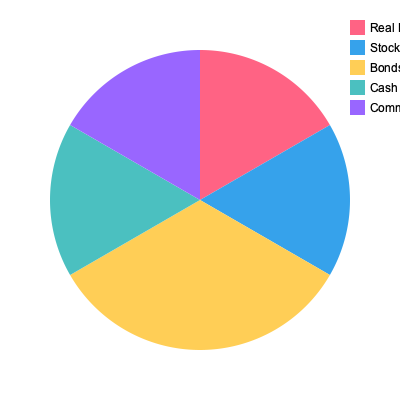Based on the pie chart showing a diversified investment portfolio, what is the combined percentage of Real Estate and Stocks investments? To find the combined percentage of Real Estate and Stocks investments, we need to:

1. Identify the percentage for Real Estate:
   Real Estate = 30%

2. Identify the percentage for Stocks:
   Stocks = 25%

3. Add these two percentages together:
   Combined percentage = Real Estate + Stocks
   Combined percentage = 30% + 25% = 55%

Therefore, the combined percentage of Real Estate and Stocks investments in this diversified portfolio is 55%.
Answer: 55% 